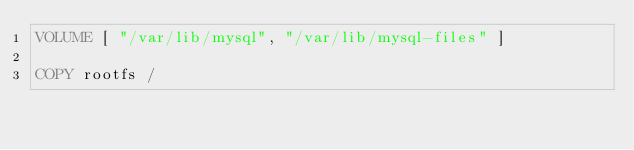<code> <loc_0><loc_0><loc_500><loc_500><_Dockerfile_>VOLUME [ "/var/lib/mysql", "/var/lib/mysql-files" ]

COPY rootfs /
</code> 